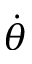Convert formula to latex. <formula><loc_0><loc_0><loc_500><loc_500>\dot { \theta }</formula> 